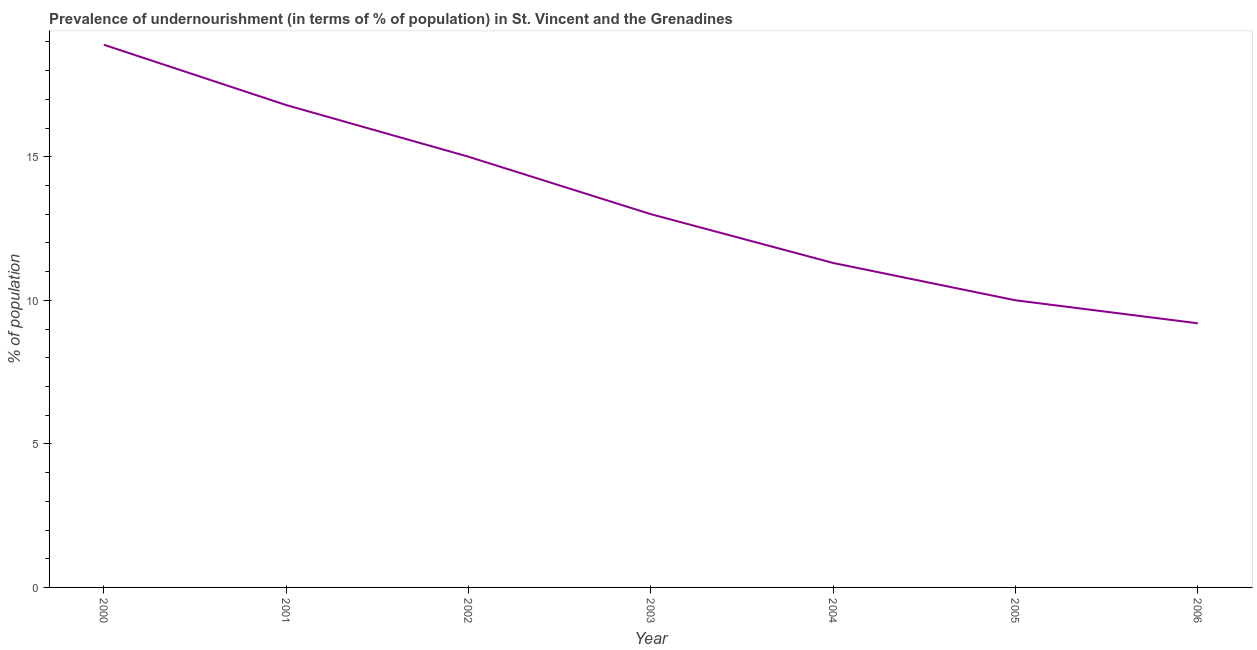What is the percentage of undernourished population in 2003?
Provide a succinct answer. 13. In which year was the percentage of undernourished population maximum?
Give a very brief answer. 2000. In which year was the percentage of undernourished population minimum?
Give a very brief answer. 2006. What is the sum of the percentage of undernourished population?
Provide a succinct answer. 94.2. What is the difference between the percentage of undernourished population in 2005 and 2006?
Your answer should be very brief. 0.8. What is the average percentage of undernourished population per year?
Give a very brief answer. 13.46. What is the median percentage of undernourished population?
Your answer should be compact. 13. In how many years, is the percentage of undernourished population greater than 9 %?
Keep it short and to the point. 7. What is the ratio of the percentage of undernourished population in 2000 to that in 2002?
Give a very brief answer. 1.26. Is the percentage of undernourished population in 2003 less than that in 2005?
Make the answer very short. No. Is the difference between the percentage of undernourished population in 2000 and 2004 greater than the difference between any two years?
Keep it short and to the point. No. What is the difference between the highest and the second highest percentage of undernourished population?
Offer a very short reply. 2.1. In how many years, is the percentage of undernourished population greater than the average percentage of undernourished population taken over all years?
Offer a very short reply. 3. How many lines are there?
Offer a terse response. 1. How many years are there in the graph?
Offer a terse response. 7. What is the difference between two consecutive major ticks on the Y-axis?
Your answer should be compact. 5. Does the graph contain grids?
Provide a succinct answer. No. What is the title of the graph?
Give a very brief answer. Prevalence of undernourishment (in terms of % of population) in St. Vincent and the Grenadines. What is the label or title of the X-axis?
Keep it short and to the point. Year. What is the label or title of the Y-axis?
Offer a terse response. % of population. What is the % of population in 2002?
Ensure brevity in your answer.  15. What is the % of population in 2003?
Offer a very short reply. 13. What is the % of population in 2005?
Give a very brief answer. 10. What is the % of population in 2006?
Provide a short and direct response. 9.2. What is the difference between the % of population in 2000 and 2002?
Give a very brief answer. 3.9. What is the difference between the % of population in 2000 and 2003?
Keep it short and to the point. 5.9. What is the difference between the % of population in 2000 and 2004?
Your answer should be very brief. 7.6. What is the difference between the % of population in 2000 and 2005?
Your response must be concise. 8.9. What is the difference between the % of population in 2000 and 2006?
Keep it short and to the point. 9.7. What is the difference between the % of population in 2001 and 2002?
Your answer should be compact. 1.8. What is the difference between the % of population in 2001 and 2006?
Keep it short and to the point. 7.6. What is the difference between the % of population in 2003 and 2004?
Provide a short and direct response. 1.7. What is the difference between the % of population in 2003 and 2005?
Provide a short and direct response. 3. What is the difference between the % of population in 2004 and 2005?
Provide a short and direct response. 1.3. What is the ratio of the % of population in 2000 to that in 2001?
Your answer should be very brief. 1.12. What is the ratio of the % of population in 2000 to that in 2002?
Offer a terse response. 1.26. What is the ratio of the % of population in 2000 to that in 2003?
Provide a succinct answer. 1.45. What is the ratio of the % of population in 2000 to that in 2004?
Offer a very short reply. 1.67. What is the ratio of the % of population in 2000 to that in 2005?
Provide a short and direct response. 1.89. What is the ratio of the % of population in 2000 to that in 2006?
Provide a short and direct response. 2.05. What is the ratio of the % of population in 2001 to that in 2002?
Your response must be concise. 1.12. What is the ratio of the % of population in 2001 to that in 2003?
Your response must be concise. 1.29. What is the ratio of the % of population in 2001 to that in 2004?
Your answer should be very brief. 1.49. What is the ratio of the % of population in 2001 to that in 2005?
Give a very brief answer. 1.68. What is the ratio of the % of population in 2001 to that in 2006?
Offer a very short reply. 1.83. What is the ratio of the % of population in 2002 to that in 2003?
Your answer should be very brief. 1.15. What is the ratio of the % of population in 2002 to that in 2004?
Ensure brevity in your answer.  1.33. What is the ratio of the % of population in 2002 to that in 2005?
Your answer should be compact. 1.5. What is the ratio of the % of population in 2002 to that in 2006?
Your answer should be very brief. 1.63. What is the ratio of the % of population in 2003 to that in 2004?
Keep it short and to the point. 1.15. What is the ratio of the % of population in 2003 to that in 2005?
Give a very brief answer. 1.3. What is the ratio of the % of population in 2003 to that in 2006?
Give a very brief answer. 1.41. What is the ratio of the % of population in 2004 to that in 2005?
Your answer should be very brief. 1.13. What is the ratio of the % of population in 2004 to that in 2006?
Your response must be concise. 1.23. What is the ratio of the % of population in 2005 to that in 2006?
Ensure brevity in your answer.  1.09. 